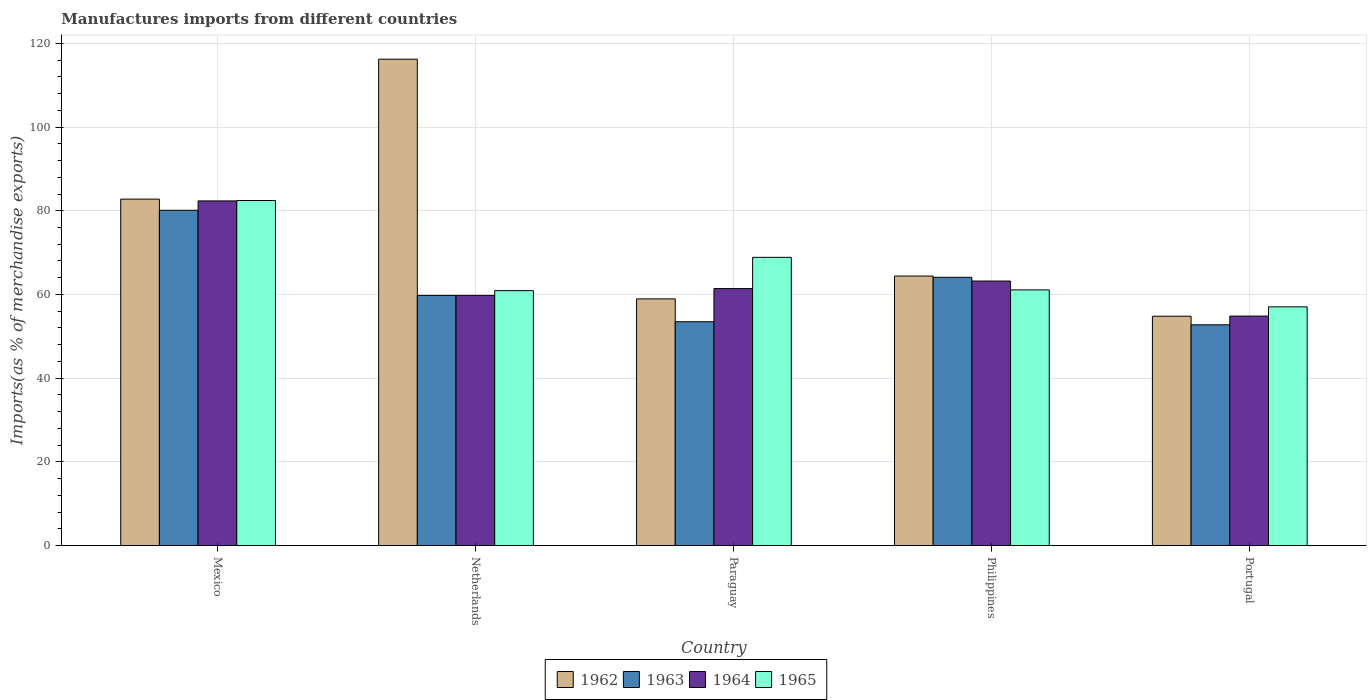How many different coloured bars are there?
Provide a short and direct response. 4. How many groups of bars are there?
Your answer should be very brief. 5. Are the number of bars on each tick of the X-axis equal?
Keep it short and to the point. Yes. How many bars are there on the 5th tick from the left?
Ensure brevity in your answer.  4. What is the label of the 3rd group of bars from the left?
Your response must be concise. Paraguay. What is the percentage of imports to different countries in 1964 in Portugal?
Provide a short and direct response. 54.83. Across all countries, what is the maximum percentage of imports to different countries in 1962?
Provide a short and direct response. 116.21. Across all countries, what is the minimum percentage of imports to different countries in 1965?
Make the answer very short. 57.04. In which country was the percentage of imports to different countries in 1962 maximum?
Make the answer very short. Netherlands. What is the total percentage of imports to different countries in 1962 in the graph?
Offer a terse response. 377.13. What is the difference between the percentage of imports to different countries in 1964 in Mexico and that in Philippines?
Ensure brevity in your answer.  19.15. What is the difference between the percentage of imports to different countries in 1962 in Portugal and the percentage of imports to different countries in 1965 in Netherlands?
Provide a short and direct response. -6.12. What is the average percentage of imports to different countries in 1965 per country?
Keep it short and to the point. 66.07. What is the difference between the percentage of imports to different countries of/in 1962 and percentage of imports to different countries of/in 1964 in Netherlands?
Your response must be concise. 56.43. What is the ratio of the percentage of imports to different countries in 1964 in Netherlands to that in Paraguay?
Offer a very short reply. 0.97. What is the difference between the highest and the second highest percentage of imports to different countries in 1962?
Offer a terse response. -18.38. What is the difference between the highest and the lowest percentage of imports to different countries in 1962?
Give a very brief answer. 61.41. Is it the case that in every country, the sum of the percentage of imports to different countries in 1964 and percentage of imports to different countries in 1965 is greater than the sum of percentage of imports to different countries in 1962 and percentage of imports to different countries in 1963?
Your response must be concise. No. What does the 1st bar from the left in Netherlands represents?
Offer a very short reply. 1962. What does the 1st bar from the right in Paraguay represents?
Offer a terse response. 1965. How many countries are there in the graph?
Ensure brevity in your answer.  5. What is the difference between two consecutive major ticks on the Y-axis?
Your answer should be compact. 20. Are the values on the major ticks of Y-axis written in scientific E-notation?
Provide a succinct answer. No. Does the graph contain grids?
Offer a very short reply. Yes. Where does the legend appear in the graph?
Keep it short and to the point. Bottom center. How many legend labels are there?
Offer a very short reply. 4. How are the legend labels stacked?
Give a very brief answer. Horizontal. What is the title of the graph?
Provide a short and direct response. Manufactures imports from different countries. What is the label or title of the X-axis?
Make the answer very short. Country. What is the label or title of the Y-axis?
Your answer should be compact. Imports(as % of merchandise exports). What is the Imports(as % of merchandise exports) in 1962 in Mexico?
Your response must be concise. 82.78. What is the Imports(as % of merchandise exports) in 1963 in Mexico?
Provide a succinct answer. 80.11. What is the Imports(as % of merchandise exports) in 1964 in Mexico?
Make the answer very short. 82.35. What is the Imports(as % of merchandise exports) of 1965 in Mexico?
Give a very brief answer. 82.44. What is the Imports(as % of merchandise exports) in 1962 in Netherlands?
Your answer should be very brief. 116.21. What is the Imports(as % of merchandise exports) in 1963 in Netherlands?
Your answer should be compact. 59.77. What is the Imports(as % of merchandise exports) in 1964 in Netherlands?
Provide a short and direct response. 59.78. What is the Imports(as % of merchandise exports) of 1965 in Netherlands?
Keep it short and to the point. 60.91. What is the Imports(as % of merchandise exports) of 1962 in Paraguay?
Give a very brief answer. 58.94. What is the Imports(as % of merchandise exports) in 1963 in Paraguay?
Your answer should be compact. 53.48. What is the Imports(as % of merchandise exports) in 1964 in Paraguay?
Ensure brevity in your answer.  61.4. What is the Imports(as % of merchandise exports) of 1965 in Paraguay?
Provide a succinct answer. 68.86. What is the Imports(as % of merchandise exports) of 1962 in Philippines?
Offer a very short reply. 64.4. What is the Imports(as % of merchandise exports) of 1963 in Philippines?
Your response must be concise. 64.1. What is the Imports(as % of merchandise exports) of 1964 in Philippines?
Your answer should be compact. 63.2. What is the Imports(as % of merchandise exports) in 1965 in Philippines?
Offer a very short reply. 61.09. What is the Imports(as % of merchandise exports) of 1962 in Portugal?
Give a very brief answer. 54.8. What is the Imports(as % of merchandise exports) of 1963 in Portugal?
Your answer should be compact. 52.75. What is the Imports(as % of merchandise exports) in 1964 in Portugal?
Ensure brevity in your answer.  54.83. What is the Imports(as % of merchandise exports) in 1965 in Portugal?
Give a very brief answer. 57.04. Across all countries, what is the maximum Imports(as % of merchandise exports) in 1962?
Your answer should be very brief. 116.21. Across all countries, what is the maximum Imports(as % of merchandise exports) of 1963?
Provide a short and direct response. 80.11. Across all countries, what is the maximum Imports(as % of merchandise exports) of 1964?
Keep it short and to the point. 82.35. Across all countries, what is the maximum Imports(as % of merchandise exports) of 1965?
Offer a terse response. 82.44. Across all countries, what is the minimum Imports(as % of merchandise exports) of 1962?
Ensure brevity in your answer.  54.8. Across all countries, what is the minimum Imports(as % of merchandise exports) of 1963?
Make the answer very short. 52.75. Across all countries, what is the minimum Imports(as % of merchandise exports) of 1964?
Your answer should be compact. 54.83. Across all countries, what is the minimum Imports(as % of merchandise exports) in 1965?
Give a very brief answer. 57.04. What is the total Imports(as % of merchandise exports) of 1962 in the graph?
Offer a terse response. 377.13. What is the total Imports(as % of merchandise exports) of 1963 in the graph?
Keep it short and to the point. 310.21. What is the total Imports(as % of merchandise exports) of 1964 in the graph?
Offer a very short reply. 321.57. What is the total Imports(as % of merchandise exports) in 1965 in the graph?
Provide a succinct answer. 330.35. What is the difference between the Imports(as % of merchandise exports) in 1962 in Mexico and that in Netherlands?
Keep it short and to the point. -33.43. What is the difference between the Imports(as % of merchandise exports) in 1963 in Mexico and that in Netherlands?
Your answer should be very brief. 20.34. What is the difference between the Imports(as % of merchandise exports) of 1964 in Mexico and that in Netherlands?
Your answer should be compact. 22.57. What is the difference between the Imports(as % of merchandise exports) in 1965 in Mexico and that in Netherlands?
Provide a short and direct response. 21.53. What is the difference between the Imports(as % of merchandise exports) of 1962 in Mexico and that in Paraguay?
Your response must be concise. 23.83. What is the difference between the Imports(as % of merchandise exports) in 1963 in Mexico and that in Paraguay?
Make the answer very short. 26.63. What is the difference between the Imports(as % of merchandise exports) of 1964 in Mexico and that in Paraguay?
Keep it short and to the point. 20.95. What is the difference between the Imports(as % of merchandise exports) of 1965 in Mexico and that in Paraguay?
Provide a succinct answer. 13.58. What is the difference between the Imports(as % of merchandise exports) of 1962 in Mexico and that in Philippines?
Offer a terse response. 18.38. What is the difference between the Imports(as % of merchandise exports) of 1963 in Mexico and that in Philippines?
Ensure brevity in your answer.  16.01. What is the difference between the Imports(as % of merchandise exports) in 1964 in Mexico and that in Philippines?
Keep it short and to the point. 19.15. What is the difference between the Imports(as % of merchandise exports) of 1965 in Mexico and that in Philippines?
Provide a short and direct response. 21.36. What is the difference between the Imports(as % of merchandise exports) in 1962 in Mexico and that in Portugal?
Ensure brevity in your answer.  27.98. What is the difference between the Imports(as % of merchandise exports) in 1963 in Mexico and that in Portugal?
Ensure brevity in your answer.  27.36. What is the difference between the Imports(as % of merchandise exports) of 1964 in Mexico and that in Portugal?
Provide a short and direct response. 27.52. What is the difference between the Imports(as % of merchandise exports) of 1965 in Mexico and that in Portugal?
Ensure brevity in your answer.  25.4. What is the difference between the Imports(as % of merchandise exports) in 1962 in Netherlands and that in Paraguay?
Make the answer very short. 57.27. What is the difference between the Imports(as % of merchandise exports) in 1963 in Netherlands and that in Paraguay?
Your response must be concise. 6.29. What is the difference between the Imports(as % of merchandise exports) of 1964 in Netherlands and that in Paraguay?
Your response must be concise. -1.63. What is the difference between the Imports(as % of merchandise exports) of 1965 in Netherlands and that in Paraguay?
Provide a short and direct response. -7.95. What is the difference between the Imports(as % of merchandise exports) in 1962 in Netherlands and that in Philippines?
Keep it short and to the point. 51.81. What is the difference between the Imports(as % of merchandise exports) in 1963 in Netherlands and that in Philippines?
Provide a succinct answer. -4.33. What is the difference between the Imports(as % of merchandise exports) of 1964 in Netherlands and that in Philippines?
Ensure brevity in your answer.  -3.42. What is the difference between the Imports(as % of merchandise exports) of 1965 in Netherlands and that in Philippines?
Keep it short and to the point. -0.17. What is the difference between the Imports(as % of merchandise exports) in 1962 in Netherlands and that in Portugal?
Offer a terse response. 61.41. What is the difference between the Imports(as % of merchandise exports) of 1963 in Netherlands and that in Portugal?
Provide a succinct answer. 7.02. What is the difference between the Imports(as % of merchandise exports) of 1964 in Netherlands and that in Portugal?
Offer a very short reply. 4.95. What is the difference between the Imports(as % of merchandise exports) of 1965 in Netherlands and that in Portugal?
Make the answer very short. 3.87. What is the difference between the Imports(as % of merchandise exports) in 1962 in Paraguay and that in Philippines?
Provide a short and direct response. -5.45. What is the difference between the Imports(as % of merchandise exports) of 1963 in Paraguay and that in Philippines?
Ensure brevity in your answer.  -10.62. What is the difference between the Imports(as % of merchandise exports) of 1964 in Paraguay and that in Philippines?
Offer a very short reply. -1.8. What is the difference between the Imports(as % of merchandise exports) of 1965 in Paraguay and that in Philippines?
Give a very brief answer. 7.78. What is the difference between the Imports(as % of merchandise exports) of 1962 in Paraguay and that in Portugal?
Offer a terse response. 4.15. What is the difference between the Imports(as % of merchandise exports) in 1963 in Paraguay and that in Portugal?
Provide a succinct answer. 0.73. What is the difference between the Imports(as % of merchandise exports) of 1964 in Paraguay and that in Portugal?
Your answer should be very brief. 6.57. What is the difference between the Imports(as % of merchandise exports) of 1965 in Paraguay and that in Portugal?
Provide a succinct answer. 11.82. What is the difference between the Imports(as % of merchandise exports) of 1962 in Philippines and that in Portugal?
Provide a succinct answer. 9.6. What is the difference between the Imports(as % of merchandise exports) of 1963 in Philippines and that in Portugal?
Offer a very short reply. 11.35. What is the difference between the Imports(as % of merchandise exports) in 1964 in Philippines and that in Portugal?
Provide a succinct answer. 8.37. What is the difference between the Imports(as % of merchandise exports) in 1965 in Philippines and that in Portugal?
Make the answer very short. 4.04. What is the difference between the Imports(as % of merchandise exports) in 1962 in Mexico and the Imports(as % of merchandise exports) in 1963 in Netherlands?
Your answer should be very brief. 23.01. What is the difference between the Imports(as % of merchandise exports) in 1962 in Mexico and the Imports(as % of merchandise exports) in 1964 in Netherlands?
Provide a short and direct response. 23. What is the difference between the Imports(as % of merchandise exports) in 1962 in Mexico and the Imports(as % of merchandise exports) in 1965 in Netherlands?
Ensure brevity in your answer.  21.86. What is the difference between the Imports(as % of merchandise exports) in 1963 in Mexico and the Imports(as % of merchandise exports) in 1964 in Netherlands?
Offer a terse response. 20.33. What is the difference between the Imports(as % of merchandise exports) in 1963 in Mexico and the Imports(as % of merchandise exports) in 1965 in Netherlands?
Provide a short and direct response. 19.19. What is the difference between the Imports(as % of merchandise exports) in 1964 in Mexico and the Imports(as % of merchandise exports) in 1965 in Netherlands?
Your answer should be compact. 21.44. What is the difference between the Imports(as % of merchandise exports) of 1962 in Mexico and the Imports(as % of merchandise exports) of 1963 in Paraguay?
Your response must be concise. 29.3. What is the difference between the Imports(as % of merchandise exports) in 1962 in Mexico and the Imports(as % of merchandise exports) in 1964 in Paraguay?
Your answer should be very brief. 21.37. What is the difference between the Imports(as % of merchandise exports) of 1962 in Mexico and the Imports(as % of merchandise exports) of 1965 in Paraguay?
Provide a short and direct response. 13.91. What is the difference between the Imports(as % of merchandise exports) of 1963 in Mexico and the Imports(as % of merchandise exports) of 1964 in Paraguay?
Provide a succinct answer. 18.7. What is the difference between the Imports(as % of merchandise exports) of 1963 in Mexico and the Imports(as % of merchandise exports) of 1965 in Paraguay?
Your answer should be compact. 11.24. What is the difference between the Imports(as % of merchandise exports) of 1964 in Mexico and the Imports(as % of merchandise exports) of 1965 in Paraguay?
Your response must be concise. 13.49. What is the difference between the Imports(as % of merchandise exports) of 1962 in Mexico and the Imports(as % of merchandise exports) of 1963 in Philippines?
Your answer should be very brief. 18.68. What is the difference between the Imports(as % of merchandise exports) of 1962 in Mexico and the Imports(as % of merchandise exports) of 1964 in Philippines?
Provide a short and direct response. 19.57. What is the difference between the Imports(as % of merchandise exports) in 1962 in Mexico and the Imports(as % of merchandise exports) in 1965 in Philippines?
Keep it short and to the point. 21.69. What is the difference between the Imports(as % of merchandise exports) of 1963 in Mexico and the Imports(as % of merchandise exports) of 1964 in Philippines?
Offer a terse response. 16.9. What is the difference between the Imports(as % of merchandise exports) of 1963 in Mexico and the Imports(as % of merchandise exports) of 1965 in Philippines?
Provide a succinct answer. 19.02. What is the difference between the Imports(as % of merchandise exports) in 1964 in Mexico and the Imports(as % of merchandise exports) in 1965 in Philippines?
Your response must be concise. 21.26. What is the difference between the Imports(as % of merchandise exports) of 1962 in Mexico and the Imports(as % of merchandise exports) of 1963 in Portugal?
Your answer should be very brief. 30.03. What is the difference between the Imports(as % of merchandise exports) of 1962 in Mexico and the Imports(as % of merchandise exports) of 1964 in Portugal?
Offer a terse response. 27.95. What is the difference between the Imports(as % of merchandise exports) in 1962 in Mexico and the Imports(as % of merchandise exports) in 1965 in Portugal?
Offer a very short reply. 25.73. What is the difference between the Imports(as % of merchandise exports) of 1963 in Mexico and the Imports(as % of merchandise exports) of 1964 in Portugal?
Make the answer very short. 25.28. What is the difference between the Imports(as % of merchandise exports) in 1963 in Mexico and the Imports(as % of merchandise exports) in 1965 in Portugal?
Give a very brief answer. 23.06. What is the difference between the Imports(as % of merchandise exports) in 1964 in Mexico and the Imports(as % of merchandise exports) in 1965 in Portugal?
Your response must be concise. 25.31. What is the difference between the Imports(as % of merchandise exports) in 1962 in Netherlands and the Imports(as % of merchandise exports) in 1963 in Paraguay?
Provide a short and direct response. 62.73. What is the difference between the Imports(as % of merchandise exports) of 1962 in Netherlands and the Imports(as % of merchandise exports) of 1964 in Paraguay?
Your answer should be compact. 54.81. What is the difference between the Imports(as % of merchandise exports) in 1962 in Netherlands and the Imports(as % of merchandise exports) in 1965 in Paraguay?
Your answer should be compact. 47.35. What is the difference between the Imports(as % of merchandise exports) of 1963 in Netherlands and the Imports(as % of merchandise exports) of 1964 in Paraguay?
Keep it short and to the point. -1.63. What is the difference between the Imports(as % of merchandise exports) of 1963 in Netherlands and the Imports(as % of merchandise exports) of 1965 in Paraguay?
Give a very brief answer. -9.09. What is the difference between the Imports(as % of merchandise exports) of 1964 in Netherlands and the Imports(as % of merchandise exports) of 1965 in Paraguay?
Offer a very short reply. -9.09. What is the difference between the Imports(as % of merchandise exports) in 1962 in Netherlands and the Imports(as % of merchandise exports) in 1963 in Philippines?
Ensure brevity in your answer.  52.11. What is the difference between the Imports(as % of merchandise exports) of 1962 in Netherlands and the Imports(as % of merchandise exports) of 1964 in Philippines?
Your answer should be very brief. 53.01. What is the difference between the Imports(as % of merchandise exports) of 1962 in Netherlands and the Imports(as % of merchandise exports) of 1965 in Philippines?
Give a very brief answer. 55.12. What is the difference between the Imports(as % of merchandise exports) of 1963 in Netherlands and the Imports(as % of merchandise exports) of 1964 in Philippines?
Keep it short and to the point. -3.43. What is the difference between the Imports(as % of merchandise exports) in 1963 in Netherlands and the Imports(as % of merchandise exports) in 1965 in Philippines?
Make the answer very short. -1.32. What is the difference between the Imports(as % of merchandise exports) of 1964 in Netherlands and the Imports(as % of merchandise exports) of 1965 in Philippines?
Give a very brief answer. -1.31. What is the difference between the Imports(as % of merchandise exports) of 1962 in Netherlands and the Imports(as % of merchandise exports) of 1963 in Portugal?
Your response must be concise. 63.46. What is the difference between the Imports(as % of merchandise exports) in 1962 in Netherlands and the Imports(as % of merchandise exports) in 1964 in Portugal?
Keep it short and to the point. 61.38. What is the difference between the Imports(as % of merchandise exports) of 1962 in Netherlands and the Imports(as % of merchandise exports) of 1965 in Portugal?
Offer a terse response. 59.17. What is the difference between the Imports(as % of merchandise exports) of 1963 in Netherlands and the Imports(as % of merchandise exports) of 1964 in Portugal?
Keep it short and to the point. 4.94. What is the difference between the Imports(as % of merchandise exports) in 1963 in Netherlands and the Imports(as % of merchandise exports) in 1965 in Portugal?
Ensure brevity in your answer.  2.73. What is the difference between the Imports(as % of merchandise exports) of 1964 in Netherlands and the Imports(as % of merchandise exports) of 1965 in Portugal?
Your response must be concise. 2.74. What is the difference between the Imports(as % of merchandise exports) in 1962 in Paraguay and the Imports(as % of merchandise exports) in 1963 in Philippines?
Your response must be concise. -5.15. What is the difference between the Imports(as % of merchandise exports) in 1962 in Paraguay and the Imports(as % of merchandise exports) in 1964 in Philippines?
Give a very brief answer. -4.26. What is the difference between the Imports(as % of merchandise exports) in 1962 in Paraguay and the Imports(as % of merchandise exports) in 1965 in Philippines?
Your answer should be very brief. -2.14. What is the difference between the Imports(as % of merchandise exports) in 1963 in Paraguay and the Imports(as % of merchandise exports) in 1964 in Philippines?
Your answer should be very brief. -9.72. What is the difference between the Imports(as % of merchandise exports) in 1963 in Paraguay and the Imports(as % of merchandise exports) in 1965 in Philippines?
Provide a succinct answer. -7.61. What is the difference between the Imports(as % of merchandise exports) in 1964 in Paraguay and the Imports(as % of merchandise exports) in 1965 in Philippines?
Provide a short and direct response. 0.32. What is the difference between the Imports(as % of merchandise exports) of 1962 in Paraguay and the Imports(as % of merchandise exports) of 1963 in Portugal?
Offer a very short reply. 6.19. What is the difference between the Imports(as % of merchandise exports) in 1962 in Paraguay and the Imports(as % of merchandise exports) in 1964 in Portugal?
Give a very brief answer. 4.11. What is the difference between the Imports(as % of merchandise exports) of 1962 in Paraguay and the Imports(as % of merchandise exports) of 1965 in Portugal?
Make the answer very short. 1.9. What is the difference between the Imports(as % of merchandise exports) of 1963 in Paraguay and the Imports(as % of merchandise exports) of 1964 in Portugal?
Offer a very short reply. -1.35. What is the difference between the Imports(as % of merchandise exports) in 1963 in Paraguay and the Imports(as % of merchandise exports) in 1965 in Portugal?
Offer a very short reply. -3.56. What is the difference between the Imports(as % of merchandise exports) of 1964 in Paraguay and the Imports(as % of merchandise exports) of 1965 in Portugal?
Provide a short and direct response. 4.36. What is the difference between the Imports(as % of merchandise exports) of 1962 in Philippines and the Imports(as % of merchandise exports) of 1963 in Portugal?
Ensure brevity in your answer.  11.65. What is the difference between the Imports(as % of merchandise exports) of 1962 in Philippines and the Imports(as % of merchandise exports) of 1964 in Portugal?
Make the answer very short. 9.57. What is the difference between the Imports(as % of merchandise exports) of 1962 in Philippines and the Imports(as % of merchandise exports) of 1965 in Portugal?
Provide a short and direct response. 7.35. What is the difference between the Imports(as % of merchandise exports) of 1963 in Philippines and the Imports(as % of merchandise exports) of 1964 in Portugal?
Ensure brevity in your answer.  9.27. What is the difference between the Imports(as % of merchandise exports) in 1963 in Philippines and the Imports(as % of merchandise exports) in 1965 in Portugal?
Make the answer very short. 7.05. What is the difference between the Imports(as % of merchandise exports) in 1964 in Philippines and the Imports(as % of merchandise exports) in 1965 in Portugal?
Provide a succinct answer. 6.16. What is the average Imports(as % of merchandise exports) in 1962 per country?
Keep it short and to the point. 75.43. What is the average Imports(as % of merchandise exports) of 1963 per country?
Your response must be concise. 62.04. What is the average Imports(as % of merchandise exports) of 1964 per country?
Your response must be concise. 64.31. What is the average Imports(as % of merchandise exports) in 1965 per country?
Your answer should be compact. 66.07. What is the difference between the Imports(as % of merchandise exports) in 1962 and Imports(as % of merchandise exports) in 1963 in Mexico?
Offer a terse response. 2.67. What is the difference between the Imports(as % of merchandise exports) of 1962 and Imports(as % of merchandise exports) of 1964 in Mexico?
Your response must be concise. 0.43. What is the difference between the Imports(as % of merchandise exports) in 1962 and Imports(as % of merchandise exports) in 1965 in Mexico?
Provide a short and direct response. 0.33. What is the difference between the Imports(as % of merchandise exports) in 1963 and Imports(as % of merchandise exports) in 1964 in Mexico?
Offer a very short reply. -2.24. What is the difference between the Imports(as % of merchandise exports) in 1963 and Imports(as % of merchandise exports) in 1965 in Mexico?
Your response must be concise. -2.34. What is the difference between the Imports(as % of merchandise exports) of 1964 and Imports(as % of merchandise exports) of 1965 in Mexico?
Your response must be concise. -0.09. What is the difference between the Imports(as % of merchandise exports) in 1962 and Imports(as % of merchandise exports) in 1963 in Netherlands?
Your answer should be very brief. 56.44. What is the difference between the Imports(as % of merchandise exports) in 1962 and Imports(as % of merchandise exports) in 1964 in Netherlands?
Offer a very short reply. 56.43. What is the difference between the Imports(as % of merchandise exports) of 1962 and Imports(as % of merchandise exports) of 1965 in Netherlands?
Give a very brief answer. 55.3. What is the difference between the Imports(as % of merchandise exports) in 1963 and Imports(as % of merchandise exports) in 1964 in Netherlands?
Provide a succinct answer. -0.01. What is the difference between the Imports(as % of merchandise exports) in 1963 and Imports(as % of merchandise exports) in 1965 in Netherlands?
Provide a succinct answer. -1.14. What is the difference between the Imports(as % of merchandise exports) of 1964 and Imports(as % of merchandise exports) of 1965 in Netherlands?
Provide a succinct answer. -1.14. What is the difference between the Imports(as % of merchandise exports) of 1962 and Imports(as % of merchandise exports) of 1963 in Paraguay?
Ensure brevity in your answer.  5.46. What is the difference between the Imports(as % of merchandise exports) in 1962 and Imports(as % of merchandise exports) in 1964 in Paraguay?
Give a very brief answer. -2.46. What is the difference between the Imports(as % of merchandise exports) of 1962 and Imports(as % of merchandise exports) of 1965 in Paraguay?
Your answer should be compact. -9.92. What is the difference between the Imports(as % of merchandise exports) of 1963 and Imports(as % of merchandise exports) of 1964 in Paraguay?
Make the answer very short. -7.92. What is the difference between the Imports(as % of merchandise exports) in 1963 and Imports(as % of merchandise exports) in 1965 in Paraguay?
Give a very brief answer. -15.38. What is the difference between the Imports(as % of merchandise exports) of 1964 and Imports(as % of merchandise exports) of 1965 in Paraguay?
Give a very brief answer. -7.46. What is the difference between the Imports(as % of merchandise exports) in 1962 and Imports(as % of merchandise exports) in 1963 in Philippines?
Provide a succinct answer. 0.3. What is the difference between the Imports(as % of merchandise exports) of 1962 and Imports(as % of merchandise exports) of 1964 in Philippines?
Give a very brief answer. 1.19. What is the difference between the Imports(as % of merchandise exports) in 1962 and Imports(as % of merchandise exports) in 1965 in Philippines?
Make the answer very short. 3.31. What is the difference between the Imports(as % of merchandise exports) of 1963 and Imports(as % of merchandise exports) of 1964 in Philippines?
Offer a very short reply. 0.89. What is the difference between the Imports(as % of merchandise exports) of 1963 and Imports(as % of merchandise exports) of 1965 in Philippines?
Your answer should be very brief. 3.01. What is the difference between the Imports(as % of merchandise exports) of 1964 and Imports(as % of merchandise exports) of 1965 in Philippines?
Ensure brevity in your answer.  2.12. What is the difference between the Imports(as % of merchandise exports) of 1962 and Imports(as % of merchandise exports) of 1963 in Portugal?
Provide a succinct answer. 2.05. What is the difference between the Imports(as % of merchandise exports) in 1962 and Imports(as % of merchandise exports) in 1964 in Portugal?
Your answer should be very brief. -0.03. What is the difference between the Imports(as % of merchandise exports) of 1962 and Imports(as % of merchandise exports) of 1965 in Portugal?
Ensure brevity in your answer.  -2.24. What is the difference between the Imports(as % of merchandise exports) of 1963 and Imports(as % of merchandise exports) of 1964 in Portugal?
Provide a short and direct response. -2.08. What is the difference between the Imports(as % of merchandise exports) of 1963 and Imports(as % of merchandise exports) of 1965 in Portugal?
Ensure brevity in your answer.  -4.29. What is the difference between the Imports(as % of merchandise exports) in 1964 and Imports(as % of merchandise exports) in 1965 in Portugal?
Ensure brevity in your answer.  -2.21. What is the ratio of the Imports(as % of merchandise exports) in 1962 in Mexico to that in Netherlands?
Keep it short and to the point. 0.71. What is the ratio of the Imports(as % of merchandise exports) of 1963 in Mexico to that in Netherlands?
Your answer should be very brief. 1.34. What is the ratio of the Imports(as % of merchandise exports) of 1964 in Mexico to that in Netherlands?
Give a very brief answer. 1.38. What is the ratio of the Imports(as % of merchandise exports) of 1965 in Mexico to that in Netherlands?
Keep it short and to the point. 1.35. What is the ratio of the Imports(as % of merchandise exports) in 1962 in Mexico to that in Paraguay?
Your answer should be very brief. 1.4. What is the ratio of the Imports(as % of merchandise exports) of 1963 in Mexico to that in Paraguay?
Provide a succinct answer. 1.5. What is the ratio of the Imports(as % of merchandise exports) in 1964 in Mexico to that in Paraguay?
Give a very brief answer. 1.34. What is the ratio of the Imports(as % of merchandise exports) of 1965 in Mexico to that in Paraguay?
Your answer should be compact. 1.2. What is the ratio of the Imports(as % of merchandise exports) in 1962 in Mexico to that in Philippines?
Keep it short and to the point. 1.29. What is the ratio of the Imports(as % of merchandise exports) in 1963 in Mexico to that in Philippines?
Provide a short and direct response. 1.25. What is the ratio of the Imports(as % of merchandise exports) in 1964 in Mexico to that in Philippines?
Your answer should be compact. 1.3. What is the ratio of the Imports(as % of merchandise exports) in 1965 in Mexico to that in Philippines?
Keep it short and to the point. 1.35. What is the ratio of the Imports(as % of merchandise exports) of 1962 in Mexico to that in Portugal?
Keep it short and to the point. 1.51. What is the ratio of the Imports(as % of merchandise exports) of 1963 in Mexico to that in Portugal?
Your answer should be very brief. 1.52. What is the ratio of the Imports(as % of merchandise exports) of 1964 in Mexico to that in Portugal?
Offer a very short reply. 1.5. What is the ratio of the Imports(as % of merchandise exports) of 1965 in Mexico to that in Portugal?
Your answer should be very brief. 1.45. What is the ratio of the Imports(as % of merchandise exports) of 1962 in Netherlands to that in Paraguay?
Ensure brevity in your answer.  1.97. What is the ratio of the Imports(as % of merchandise exports) in 1963 in Netherlands to that in Paraguay?
Provide a succinct answer. 1.12. What is the ratio of the Imports(as % of merchandise exports) in 1964 in Netherlands to that in Paraguay?
Provide a succinct answer. 0.97. What is the ratio of the Imports(as % of merchandise exports) in 1965 in Netherlands to that in Paraguay?
Your response must be concise. 0.88. What is the ratio of the Imports(as % of merchandise exports) in 1962 in Netherlands to that in Philippines?
Make the answer very short. 1.8. What is the ratio of the Imports(as % of merchandise exports) in 1963 in Netherlands to that in Philippines?
Offer a terse response. 0.93. What is the ratio of the Imports(as % of merchandise exports) of 1964 in Netherlands to that in Philippines?
Give a very brief answer. 0.95. What is the ratio of the Imports(as % of merchandise exports) in 1965 in Netherlands to that in Philippines?
Your answer should be very brief. 1. What is the ratio of the Imports(as % of merchandise exports) of 1962 in Netherlands to that in Portugal?
Offer a terse response. 2.12. What is the ratio of the Imports(as % of merchandise exports) of 1963 in Netherlands to that in Portugal?
Provide a succinct answer. 1.13. What is the ratio of the Imports(as % of merchandise exports) of 1964 in Netherlands to that in Portugal?
Your response must be concise. 1.09. What is the ratio of the Imports(as % of merchandise exports) of 1965 in Netherlands to that in Portugal?
Offer a terse response. 1.07. What is the ratio of the Imports(as % of merchandise exports) of 1962 in Paraguay to that in Philippines?
Provide a short and direct response. 0.92. What is the ratio of the Imports(as % of merchandise exports) in 1963 in Paraguay to that in Philippines?
Offer a very short reply. 0.83. What is the ratio of the Imports(as % of merchandise exports) in 1964 in Paraguay to that in Philippines?
Make the answer very short. 0.97. What is the ratio of the Imports(as % of merchandise exports) of 1965 in Paraguay to that in Philippines?
Offer a very short reply. 1.13. What is the ratio of the Imports(as % of merchandise exports) in 1962 in Paraguay to that in Portugal?
Offer a terse response. 1.08. What is the ratio of the Imports(as % of merchandise exports) in 1963 in Paraguay to that in Portugal?
Give a very brief answer. 1.01. What is the ratio of the Imports(as % of merchandise exports) in 1964 in Paraguay to that in Portugal?
Ensure brevity in your answer.  1.12. What is the ratio of the Imports(as % of merchandise exports) in 1965 in Paraguay to that in Portugal?
Ensure brevity in your answer.  1.21. What is the ratio of the Imports(as % of merchandise exports) in 1962 in Philippines to that in Portugal?
Ensure brevity in your answer.  1.18. What is the ratio of the Imports(as % of merchandise exports) in 1963 in Philippines to that in Portugal?
Offer a terse response. 1.22. What is the ratio of the Imports(as % of merchandise exports) of 1964 in Philippines to that in Portugal?
Offer a very short reply. 1.15. What is the ratio of the Imports(as % of merchandise exports) in 1965 in Philippines to that in Portugal?
Keep it short and to the point. 1.07. What is the difference between the highest and the second highest Imports(as % of merchandise exports) of 1962?
Ensure brevity in your answer.  33.43. What is the difference between the highest and the second highest Imports(as % of merchandise exports) in 1963?
Offer a terse response. 16.01. What is the difference between the highest and the second highest Imports(as % of merchandise exports) of 1964?
Your answer should be very brief. 19.15. What is the difference between the highest and the second highest Imports(as % of merchandise exports) in 1965?
Keep it short and to the point. 13.58. What is the difference between the highest and the lowest Imports(as % of merchandise exports) in 1962?
Provide a succinct answer. 61.41. What is the difference between the highest and the lowest Imports(as % of merchandise exports) of 1963?
Keep it short and to the point. 27.36. What is the difference between the highest and the lowest Imports(as % of merchandise exports) of 1964?
Ensure brevity in your answer.  27.52. What is the difference between the highest and the lowest Imports(as % of merchandise exports) of 1965?
Your answer should be compact. 25.4. 